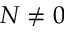<formula> <loc_0><loc_0><loc_500><loc_500>N \neq 0</formula> 